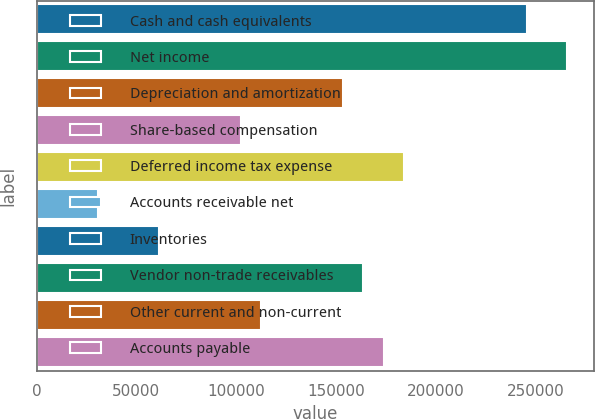Convert chart to OTSL. <chart><loc_0><loc_0><loc_500><loc_500><bar_chart><fcel>Cash and cash equivalents<fcel>Net income<fcel>Depreciation and amortization<fcel>Share-based compensation<fcel>Deferred income tax expense<fcel>Accounts receivable net<fcel>Inventories<fcel>Vendor non-trade receivables<fcel>Other current and non-current<fcel>Accounts payable<nl><fcel>245559<fcel>266022<fcel>153475<fcel>102317<fcel>184170<fcel>30695.9<fcel>61390.7<fcel>163706<fcel>112549<fcel>173938<nl></chart> 